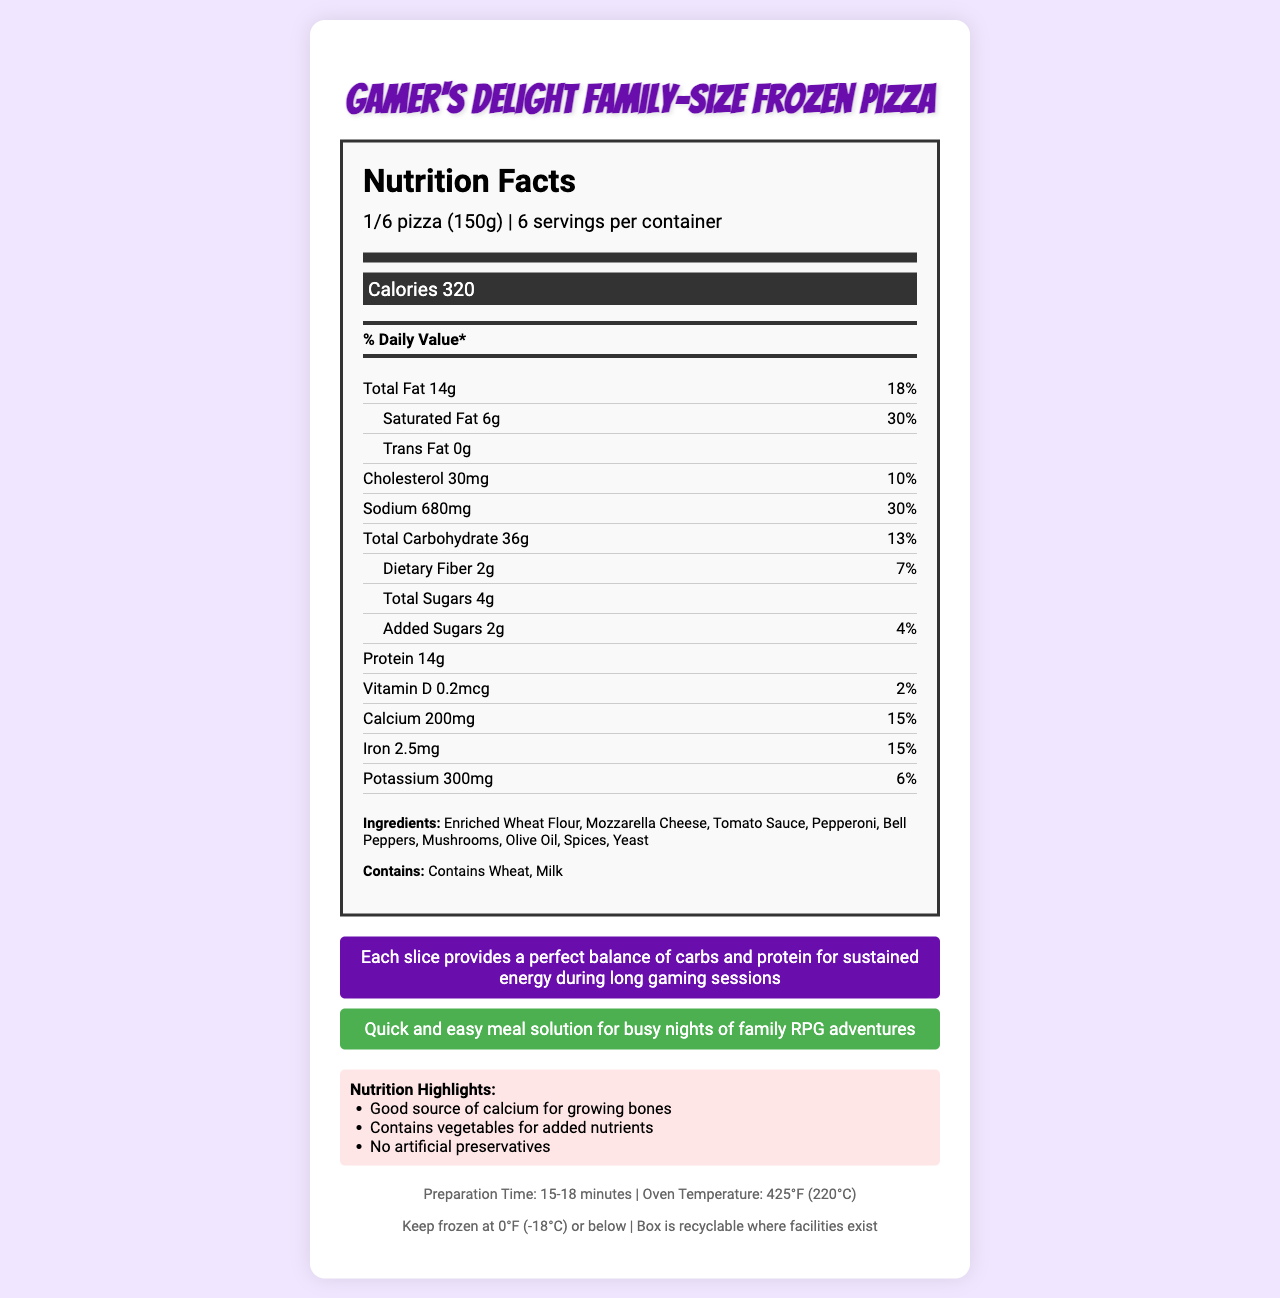What is the serving size of the Gamer's Delight Family-Size Frozen Pizza? The serving size is specified in the document as "1/6 pizza (150g)".
Answer: 1/6 pizza (150g) How many servings are there per container? The document states there are 6 servings per container.
Answer: 6 How many calories are there per serving of the pizza? The calorie count per serving is listed as 320.
Answer: 320 What is the total fat content per serving, and what percentage of the daily value does it represent? The document indicates that the total fat content is 14g per serving, which is 18% of the daily value.
Answer: 14g, 18% What are the primary allergens in this pizza? The document specifies that the allergens in the pizza are wheat and milk.
Answer: Wheat, Milk What is the main nutrient highlighted for bone health in the Gamer's Delight Family-Size Frozen Pizza? 
A. Vitamin D 
B. Iron 
C. Calcium 
D. Protein The document highlights that the pizza is a good source of calcium for growing bones.
Answer: C How long does it take to prepare the frozen pizza?
A. 10-12 minutes
B. 15-18 minutes
C. 20-22 minutes
D. 25-30 minutes The document states that the preparation time is 15-18 minutes.
Answer: B Does the pizza contain any artificial preservatives? The document states that the pizza contains no artificial preservatives.
Answer: No Summarize the main idea of the document. The document highlights the product's nutrition facts, preparation instructions, and benefits, focusing on its suitability for busy family gaming nights.
Answer: The Gamer's Delight Family-Size Frozen Pizza is a convenient, family-sized meal designed for busy gaming nights. It offers balanced nutrients, with each serving containing 320 calories, 14g of fat, and 14g of protein. It is rich in calcium, contains vegetables, and has no artificial preservatives. The pizza is quick to prepare, taking only 15-18 minutes at 425°F, and is mom-approved for its ease of preparation and nutritional benefits. What is the price of the Gamer's Delight Family-Size Frozen Pizza? The document does not provide the price of the pizza.
Answer: Not enough information 